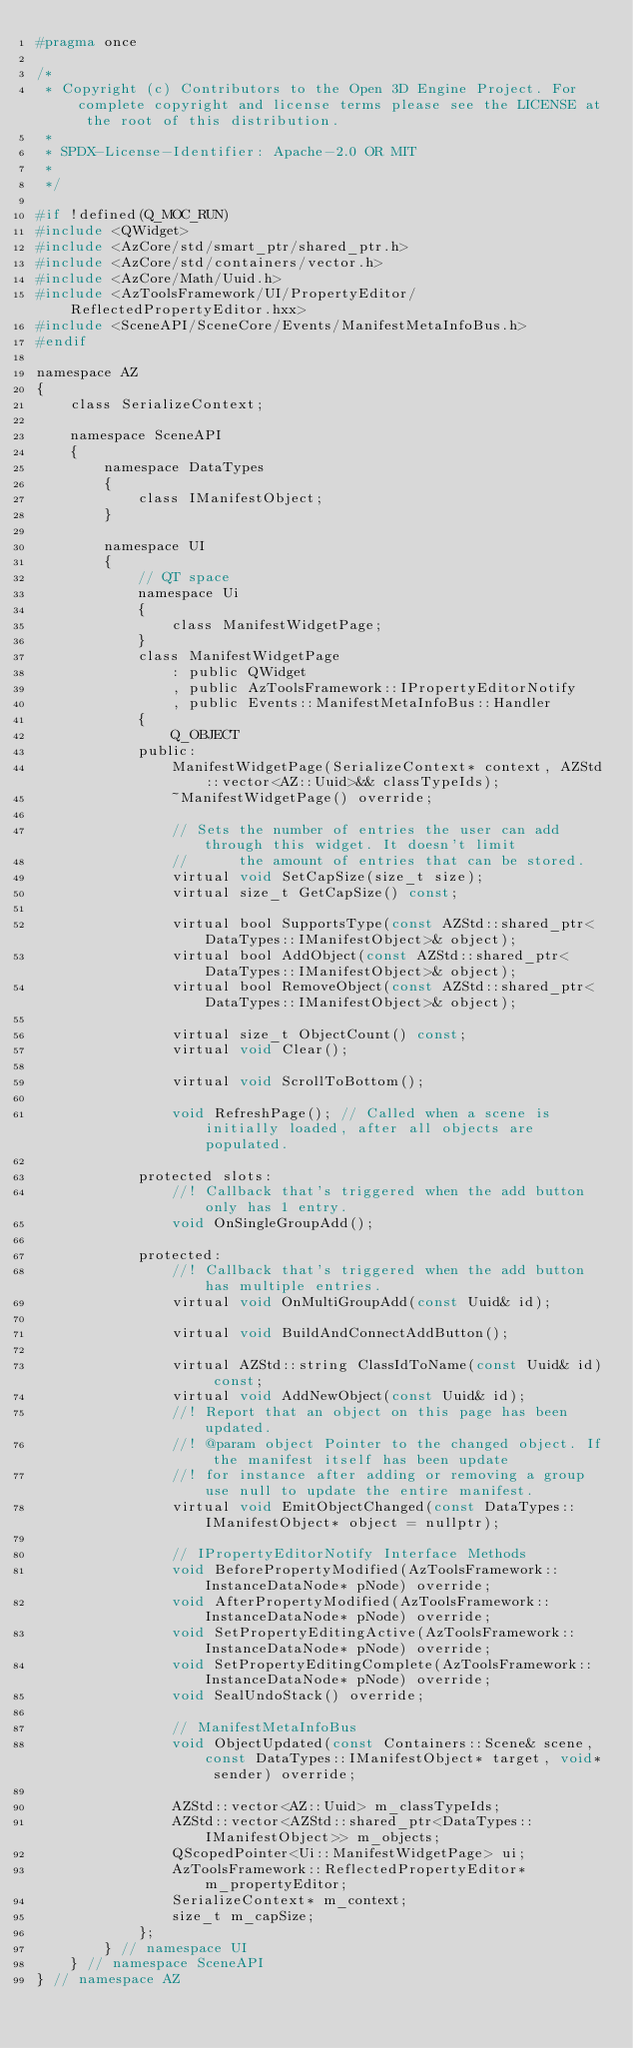<code> <loc_0><loc_0><loc_500><loc_500><_C_>#pragma once

/*
 * Copyright (c) Contributors to the Open 3D Engine Project. For complete copyright and license terms please see the LICENSE at the root of this distribution.
 * 
 * SPDX-License-Identifier: Apache-2.0 OR MIT
 *
 */

#if !defined(Q_MOC_RUN)
#include <QWidget>
#include <AzCore/std/smart_ptr/shared_ptr.h>
#include <AzCore/std/containers/vector.h>
#include <AzCore/Math/Uuid.h>
#include <AzToolsFramework/UI/PropertyEditor/ReflectedPropertyEditor.hxx>
#include <SceneAPI/SceneCore/Events/ManifestMetaInfoBus.h>
#endif

namespace AZ
{
    class SerializeContext;

    namespace SceneAPI
    {
        namespace DataTypes
        {
            class IManifestObject;
        }

        namespace UI
        {
            // QT space
            namespace Ui
            {
                class ManifestWidgetPage;
            }
            class ManifestWidgetPage 
                : public QWidget
                , public AzToolsFramework::IPropertyEditorNotify
                , public Events::ManifestMetaInfoBus::Handler
            {
                Q_OBJECT
            public:
                ManifestWidgetPage(SerializeContext* context, AZStd::vector<AZ::Uuid>&& classTypeIds);
                ~ManifestWidgetPage() override;

                // Sets the number of entries the user can add through this widget. It doesn't limit
                //      the amount of entries that can be stored.
                virtual void SetCapSize(size_t size);
                virtual size_t GetCapSize() const;

                virtual bool SupportsType(const AZStd::shared_ptr<DataTypes::IManifestObject>& object);
                virtual bool AddObject(const AZStd::shared_ptr<DataTypes::IManifestObject>& object);
                virtual bool RemoveObject(const AZStd::shared_ptr<DataTypes::IManifestObject>& object);

                virtual size_t ObjectCount() const;
                virtual void Clear();

                virtual void ScrollToBottom();

                void RefreshPage(); // Called when a scene is initially loaded, after all objects are populated.

            protected slots:
                //! Callback that's triggered when the add button only has 1 entry.
                void OnSingleGroupAdd();

            protected:
                //! Callback that's triggered when the add button has multiple entries.
                virtual void OnMultiGroupAdd(const Uuid& id);

                virtual void BuildAndConnectAddButton();
                
                virtual AZStd::string ClassIdToName(const Uuid& id) const;
                virtual void AddNewObject(const Uuid& id);
                //! Report that an object on this page has been updated.
                //! @param object Pointer to the changed object. If the manifest itself has been update
                //! for instance after adding or removing a group use null to update the entire manifest.
                virtual void EmitObjectChanged(const DataTypes::IManifestObject* object = nullptr);

                // IPropertyEditorNotify Interface Methods
                void BeforePropertyModified(AzToolsFramework::InstanceDataNode* pNode) override;
                void AfterPropertyModified(AzToolsFramework::InstanceDataNode* pNode) override;
                void SetPropertyEditingActive(AzToolsFramework::InstanceDataNode* pNode) override;
                void SetPropertyEditingComplete(AzToolsFramework::InstanceDataNode* pNode) override;
                void SealUndoStack() override;

                // ManifestMetaInfoBus
                void ObjectUpdated(const Containers::Scene& scene, const DataTypes::IManifestObject* target, void* sender) override;

                AZStd::vector<AZ::Uuid> m_classTypeIds;
                AZStd::vector<AZStd::shared_ptr<DataTypes::IManifestObject>> m_objects;
                QScopedPointer<Ui::ManifestWidgetPage> ui;
                AzToolsFramework::ReflectedPropertyEditor* m_propertyEditor;
                SerializeContext* m_context;
                size_t m_capSize;
            };
        } // namespace UI
    } // namespace SceneAPI
} // namespace AZ
</code> 